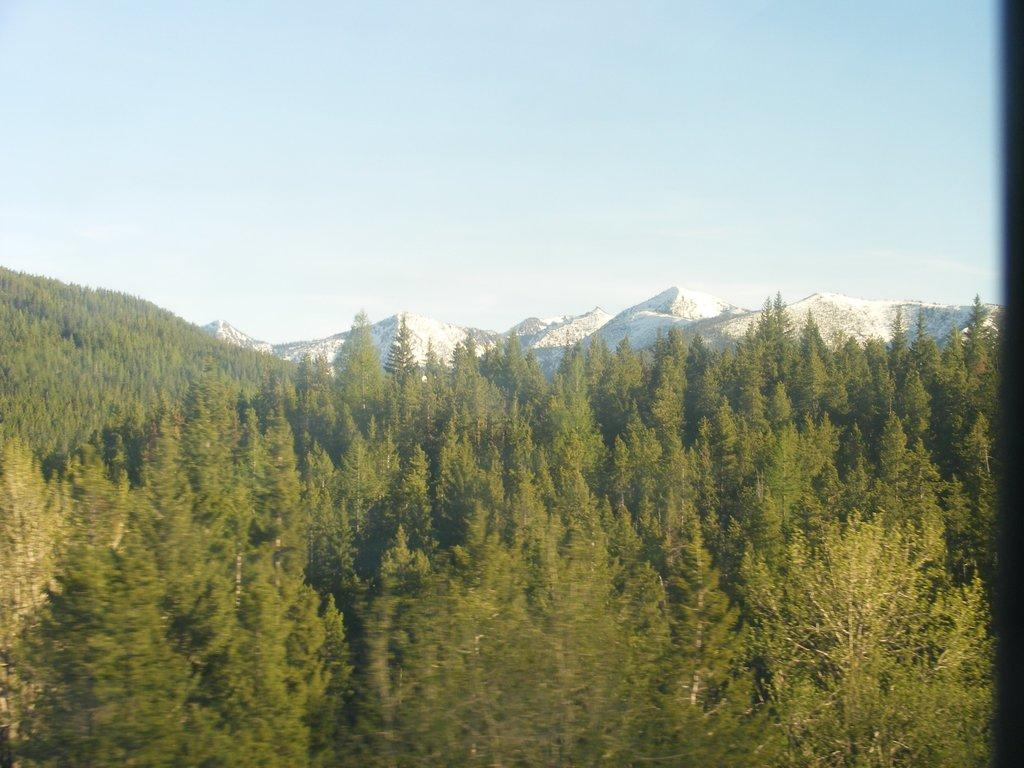What can be seen in the sky in the image? The sky is visible in the image, but no specific details about the sky are mentioned. What type of geographical feature is present in the image? There are mountains in the image. What type of vegetation can be seen in the image? Trees are present in the image. Can you tell me how many trucks are visible in the image? There are no trucks present in the image. What type of lift is used to reach the top of the mountains in the image? There is no lift present in the image, and the mountains are not depicted as being climbed or traversed. 